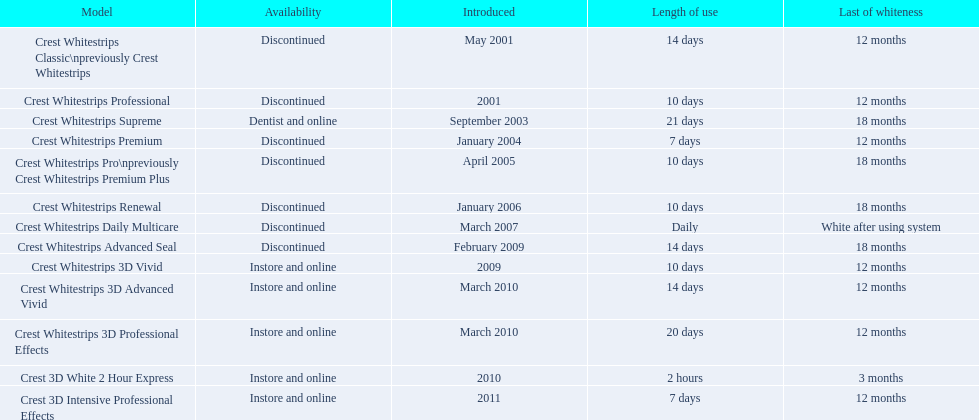When was crest whitestrips 3d advanced vivid launched? March 2010. What additional product was released in march 2010? Crest Whitestrips 3D Professional Effects. 